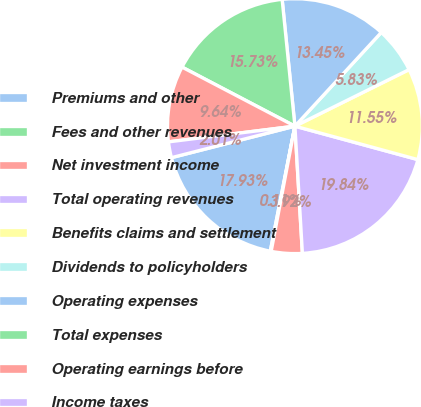Convert chart to OTSL. <chart><loc_0><loc_0><loc_500><loc_500><pie_chart><fcel>Premiums and other<fcel>Fees and other revenues<fcel>Net investment income<fcel>Total operating revenues<fcel>Benefits claims and settlement<fcel>Dividends to policyholders<fcel>Operating expenses<fcel>Total expenses<fcel>Operating earnings before<fcel>Income taxes<nl><fcel>17.93%<fcel>0.11%<fcel>3.92%<fcel>19.84%<fcel>11.55%<fcel>5.83%<fcel>13.45%<fcel>15.73%<fcel>9.64%<fcel>2.01%<nl></chart> 